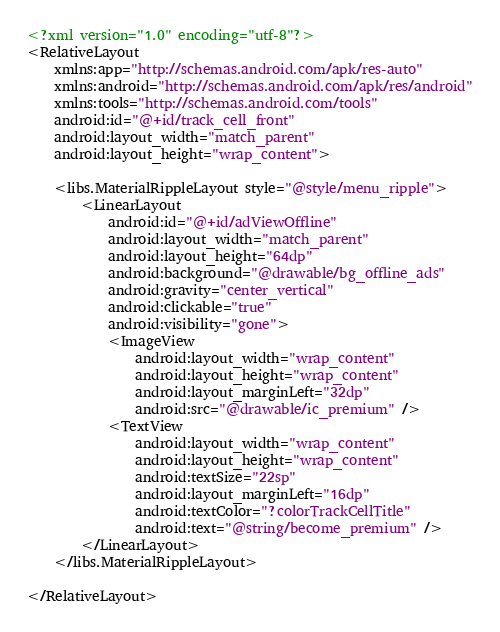<code> <loc_0><loc_0><loc_500><loc_500><_XML_><?xml version="1.0" encoding="utf-8"?>
<RelativeLayout
    xmlns:app="http://schemas.android.com/apk/res-auto"
    xmlns:android="http://schemas.android.com/apk/res/android"
    xmlns:tools="http://schemas.android.com/tools"
    android:id="@+id/track_cell_front"
    android:layout_width="match_parent"
    android:layout_height="wrap_content">

    <libs.MaterialRippleLayout style="@style/menu_ripple">
        <LinearLayout
            android:id="@+id/adViewOffline"
            android:layout_width="match_parent"
            android:layout_height="64dp"
            android:background="@drawable/bg_offline_ads"
            android:gravity="center_vertical"
            android:clickable="true"
            android:visibility="gone">
            <ImageView
                android:layout_width="wrap_content"
                android:layout_height="wrap_content"
                android:layout_marginLeft="32dp"
                android:src="@drawable/ic_premium" />
            <TextView
                android:layout_width="wrap_content"
                android:layout_height="wrap_content"
                android:textSize="22sp"
                android:layout_marginLeft="16dp"
                android:textColor="?colorTrackCellTitle"
                android:text="@string/become_premium" />
        </LinearLayout>
    </libs.MaterialRippleLayout>

</RelativeLayout>
</code> 